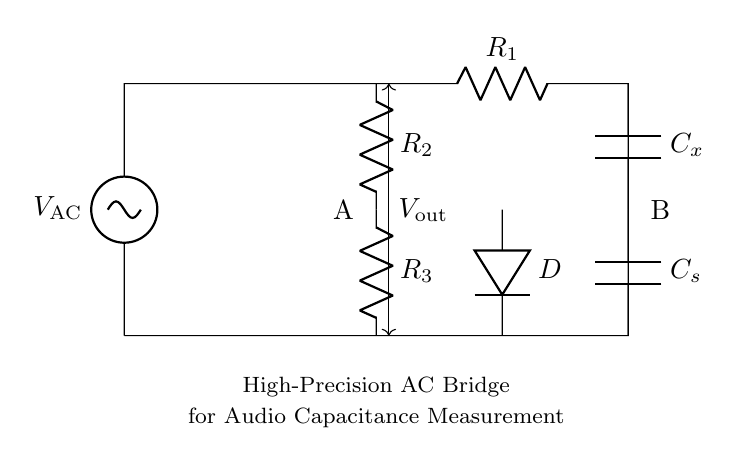What type of circuit is this? This is a high-precision AC bridge circuit designed for capacitance measurement. The components and layout are typical of bridge circuits used in precise measurement applications.
Answer: AC bridge What are the components labeled R1, R2, and R3? These components are resistors. R1 and R2 are part of the bridge configuration, while R3 helps in stabilizing the circuit for accurate measurements.
Answer: Resistors What is the function of the capacitor Cx? Cx represents the unknown capacitance that is being measured with the bridge circuit. This is the primary capacitor of interest in this setup.
Answer: Unknown capacitance What does the voltage label Vout indicate? Vout represents the output voltage of the bridge circuit, which is measured to determine the balance of the bridge and thus the value of Cx.
Answer: Output voltage How many resistors are present in the circuit? There are three resistors present in the circuit: R1, R2, and R3, which are critical for measuring capacitance and stabilizing the output.
Answer: Three What role does the diode D serve in this circuit? The diode D likely helps in rectifying the output voltage, ensuring the measurement is suitable for analysis as it converts AC to a more manageable DC form.
Answer: Rectification What condition is needed for the bridge to achieve balance? For the bridge to be balanced, the ratio of R1 to R2 must equal the ratio of Cx to Cs, which is necessary to simplify the calculation of the unknown capacitance.
Answer: Ratio equality 